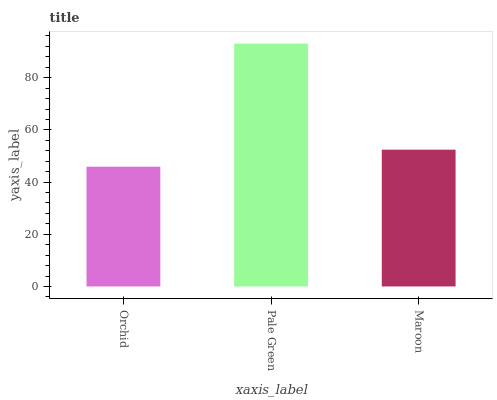Is Orchid the minimum?
Answer yes or no. Yes. Is Pale Green the maximum?
Answer yes or no. Yes. Is Maroon the minimum?
Answer yes or no. No. Is Maroon the maximum?
Answer yes or no. No. Is Pale Green greater than Maroon?
Answer yes or no. Yes. Is Maroon less than Pale Green?
Answer yes or no. Yes. Is Maroon greater than Pale Green?
Answer yes or no. No. Is Pale Green less than Maroon?
Answer yes or no. No. Is Maroon the high median?
Answer yes or no. Yes. Is Maroon the low median?
Answer yes or no. Yes. Is Orchid the high median?
Answer yes or no. No. Is Pale Green the low median?
Answer yes or no. No. 